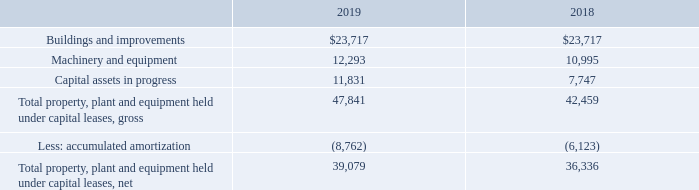3. Property, Plant and Equipment
Assets held under capital leases and included in property, plant and equipment as of September 28, 2019 and September 29, 2018 consisted of the following (in thousands):
Amortization of assets held under capital leases totaled $3.8 million, $3.4 million and $3.0 million for fiscal 2019, 2018 and 2017, respectively. Capital lease additions totaled $6.7 million, $11.8 million, and $20.5 million for fiscal 2019, 2018 and 2017, respectively.
As of September 28, 2019, September 29, 2018 and September 30, 2017, accounts payable included approximately $10.0 million, $11.2 million and $10.8 million, respectively, related to the purchase of property, plant and equipment, which have been treated as non-cash transactions for purposes of the Consolidated Statements of Cash Flows.
What was the Amortization of assets held under capital leases in 2017?
Answer scale should be: million. 3.0. What was the amount of capital assets in progress in 2018?
Answer scale should be: thousand. 7,747. What was the net Total property, plant and equipment held under capital leases in 2019?
Answer scale should be: thousand. 39,079. How many years did the Capital assets in progress exceed $10,000 thousand? 2019
Answer: 1. What was the change in the gross Total property, plant and equipment held under capital leases between 2018 and 2019?
Answer scale should be: thousand. 47,841-42,459
Answer: 5382. What was the percentage change in the accumulated amortization between 2018 and 2019?
Answer scale should be: percent. (-8,762-(-6,123))/-6,123
Answer: 43.1. 